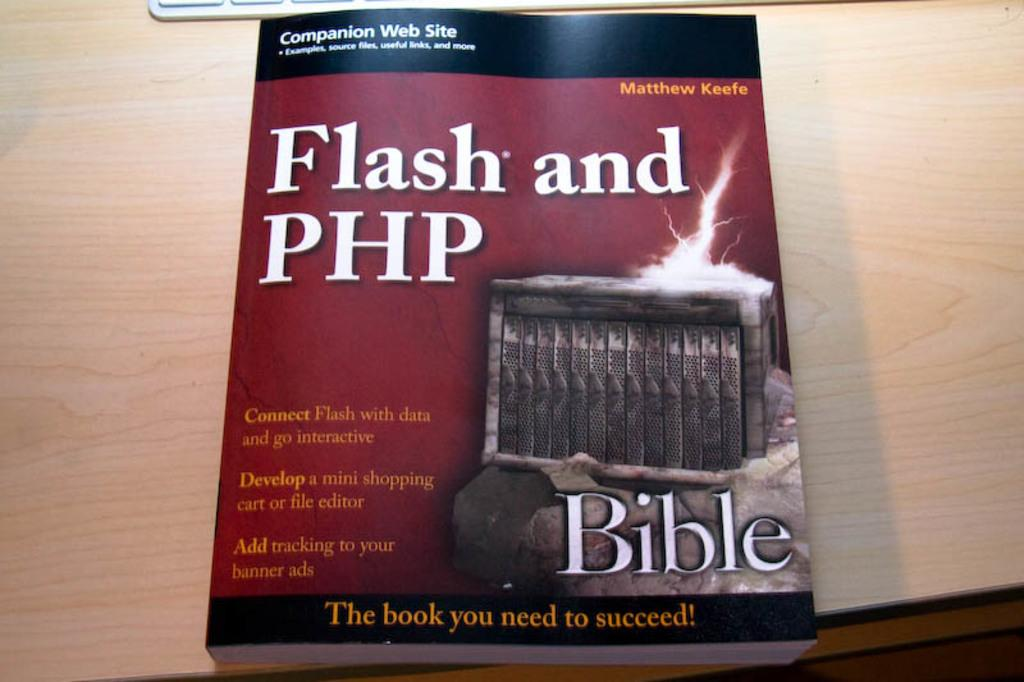<image>
Share a concise interpretation of the image provided. A book on a wooden table about Flash and PHP. 